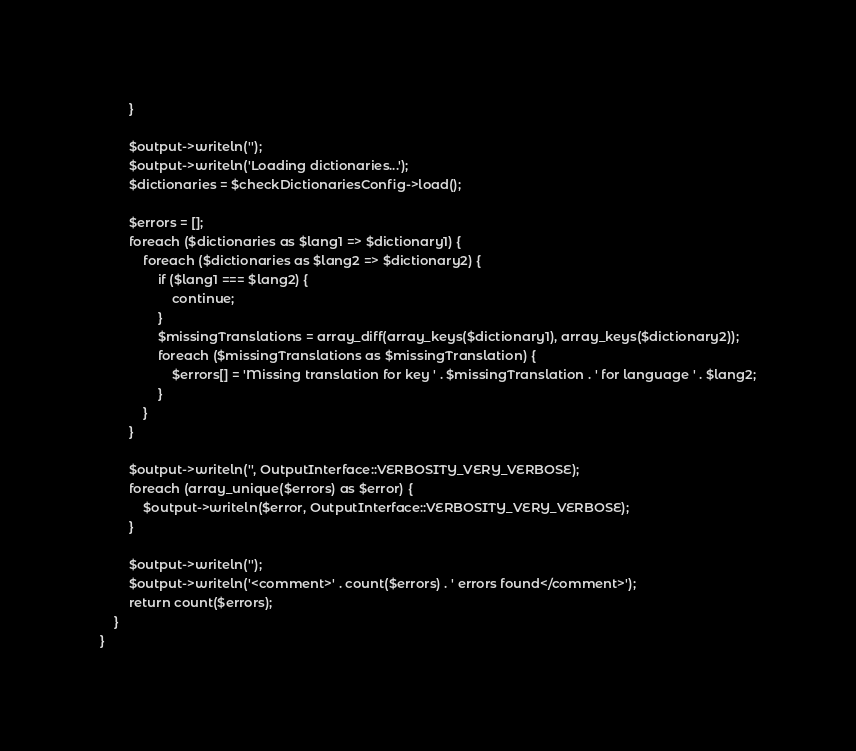Convert code to text. <code><loc_0><loc_0><loc_500><loc_500><_PHP_>        }

        $output->writeln('');
        $output->writeln('Loading dictionaries...');
        $dictionaries = $checkDictionariesConfig->load();

        $errors = [];
        foreach ($dictionaries as $lang1 => $dictionary1) {
            foreach ($dictionaries as $lang2 => $dictionary2) {
                if ($lang1 === $lang2) {
                    continue;
                }
                $missingTranslations = array_diff(array_keys($dictionary1), array_keys($dictionary2));
                foreach ($missingTranslations as $missingTranslation) {
                    $errors[] = 'Missing translation for key ' . $missingTranslation . ' for language ' . $lang2;
                }
            }
        }

        $output->writeln('', OutputInterface::VERBOSITY_VERY_VERBOSE);
        foreach (array_unique($errors) as $error) {
            $output->writeln($error, OutputInterface::VERBOSITY_VERY_VERBOSE);
        }

        $output->writeln('');
        $output->writeln('<comment>' . count($errors) . ' errors found</comment>');
        return count($errors);
    }
}
</code> 